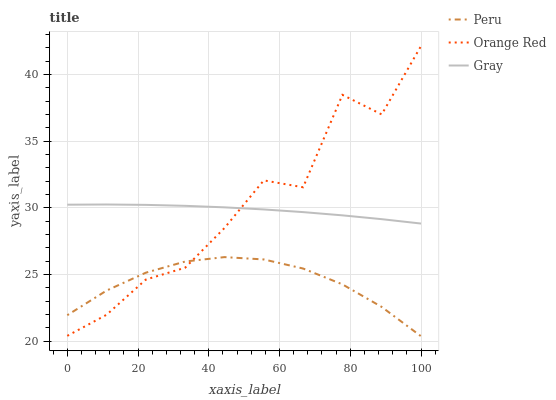Does Peru have the minimum area under the curve?
Answer yes or no. Yes. Does Orange Red have the maximum area under the curve?
Answer yes or no. Yes. Does Orange Red have the minimum area under the curve?
Answer yes or no. No. Does Peru have the maximum area under the curve?
Answer yes or no. No. Is Gray the smoothest?
Answer yes or no. Yes. Is Orange Red the roughest?
Answer yes or no. Yes. Is Peru the smoothest?
Answer yes or no. No. Is Peru the roughest?
Answer yes or no. No. Does Peru have the lowest value?
Answer yes or no. Yes. Does Orange Red have the lowest value?
Answer yes or no. No. Does Orange Red have the highest value?
Answer yes or no. Yes. Does Peru have the highest value?
Answer yes or no. No. Is Peru less than Gray?
Answer yes or no. Yes. Is Gray greater than Peru?
Answer yes or no. Yes. Does Orange Red intersect Gray?
Answer yes or no. Yes. Is Orange Red less than Gray?
Answer yes or no. No. Is Orange Red greater than Gray?
Answer yes or no. No. Does Peru intersect Gray?
Answer yes or no. No. 